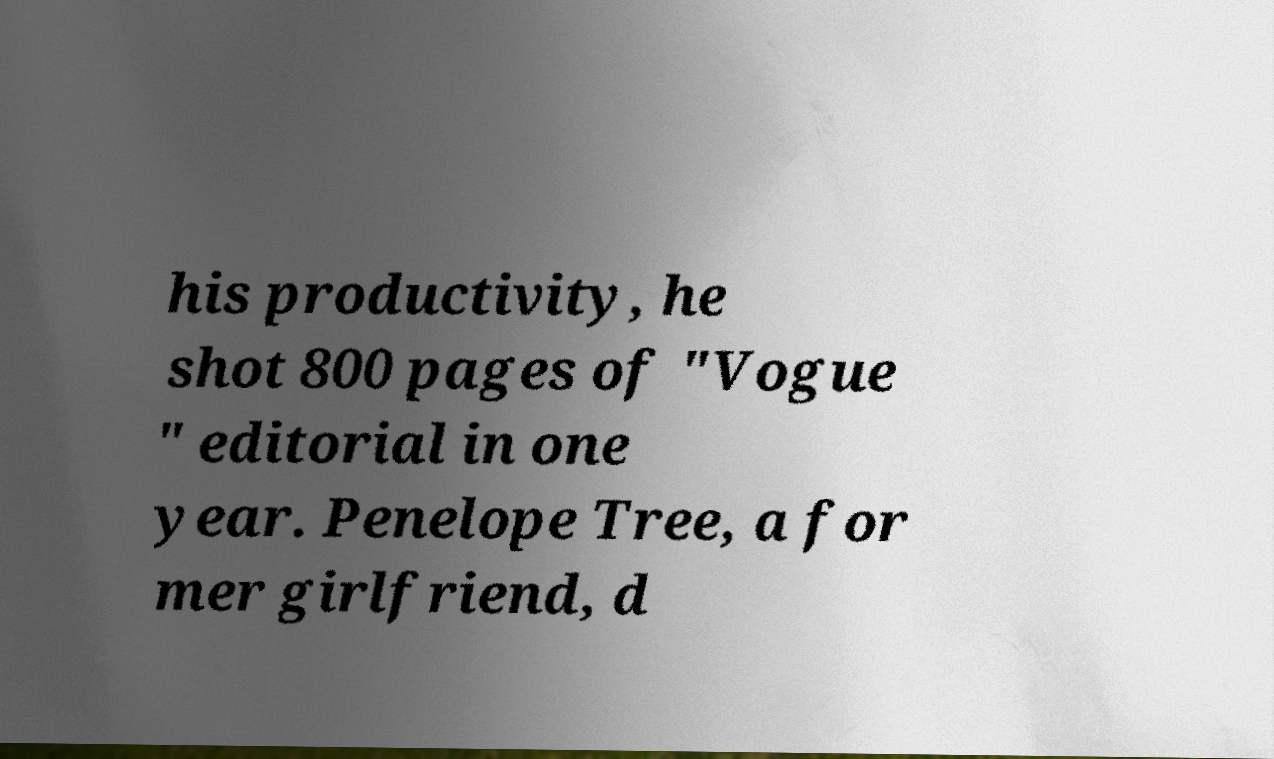Please read and relay the text visible in this image. What does it say? his productivity, he shot 800 pages of "Vogue " editorial in one year. Penelope Tree, a for mer girlfriend, d 